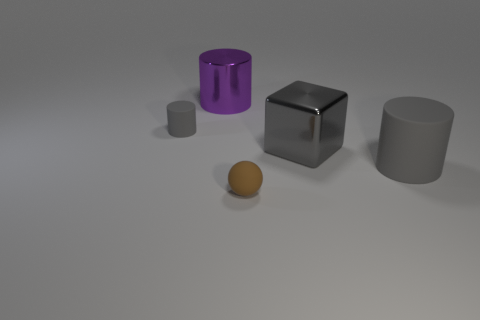There is a large block that is the same material as the large purple thing; what color is it?
Ensure brevity in your answer.  Gray. How many cylinders have the same size as the brown rubber object?
Your answer should be compact. 1. There is a rubber cylinder that is left of the purple thing; does it have the same size as the big gray matte thing?
Give a very brief answer. No. There is a rubber object that is both left of the gray shiny block and in front of the gray cube; what shape is it?
Provide a short and direct response. Sphere. There is a large purple metallic object; are there any gray shiny blocks behind it?
Keep it short and to the point. No. Is there anything else that is the same shape as the small brown matte thing?
Offer a terse response. No. Do the big purple thing and the big matte object have the same shape?
Your answer should be compact. Yes. Is the number of purple metallic cylinders on the right side of the brown object the same as the number of big gray blocks that are in front of the large gray cylinder?
Make the answer very short. Yes. What number of other objects are there of the same material as the purple cylinder?
Give a very brief answer. 1. What number of tiny things are purple cylinders or red rubber objects?
Provide a short and direct response. 0. 